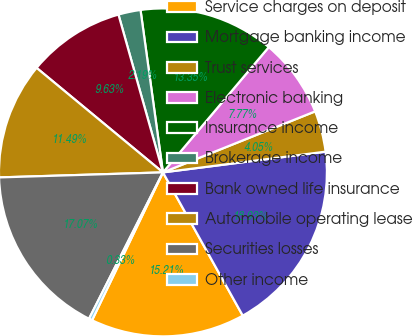Convert chart to OTSL. <chart><loc_0><loc_0><loc_500><loc_500><pie_chart><fcel>Service charges on deposit<fcel>Mortgage banking income<fcel>Trust services<fcel>Electronic banking<fcel>Insurance income<fcel>Brokerage income<fcel>Bank owned life insurance<fcel>Automobile operating lease<fcel>Securities losses<fcel>Other income<nl><fcel>15.21%<fcel>18.93%<fcel>4.05%<fcel>7.77%<fcel>13.35%<fcel>2.19%<fcel>9.63%<fcel>11.49%<fcel>17.07%<fcel>0.33%<nl></chart> 